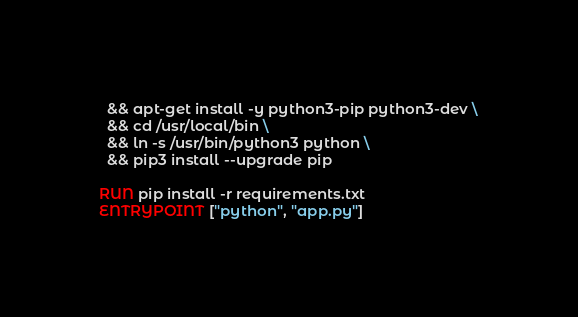<code> <loc_0><loc_0><loc_500><loc_500><_Dockerfile_>  && apt-get install -y python3-pip python3-dev \
  && cd /usr/local/bin \
  && ln -s /usr/bin/python3 python \
  && pip3 install --upgrade pip

RUN pip install -r requirements.txt
ENTRYPOINT ["python", "app.py"]
</code> 